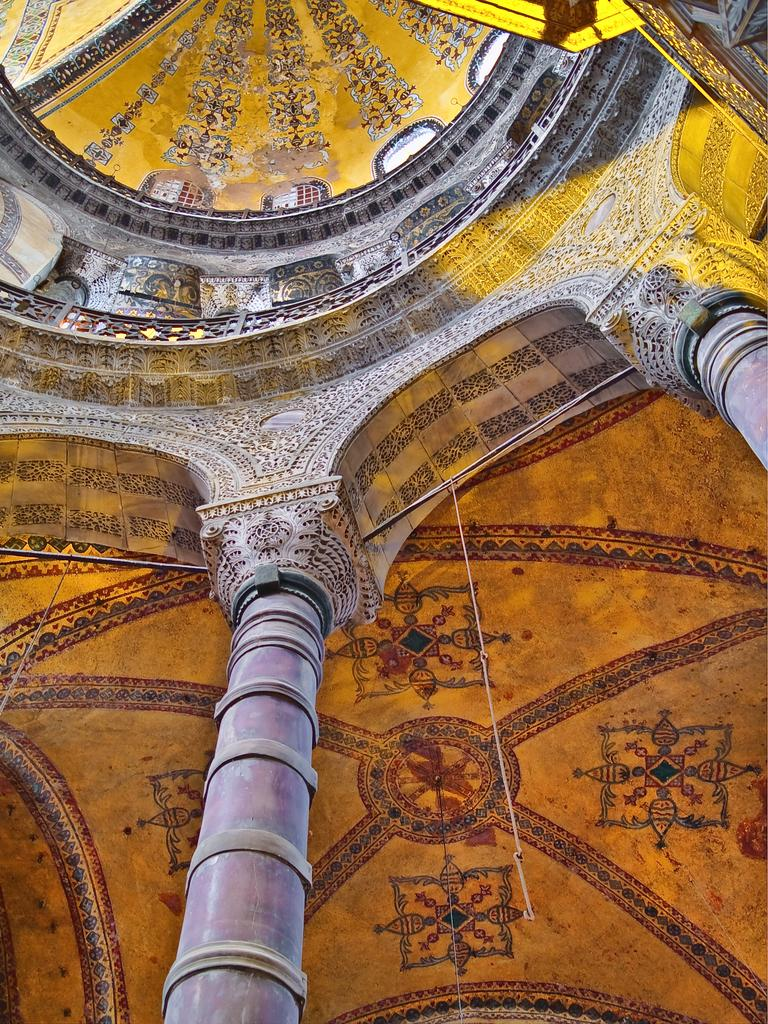What type of location is depicted in the image? The image appears to be an interior view of a building. What architectural features can be seen in the image? There are two pillars visible in the image. What is located at the top of the image? There is a dome at the top of the image. What type of soda is being served in the image? There is no soda present in the image; it depicts an interior view of a building with pillars and a dome. What type of suit is the person wearing in the image? There are no people visible in the image, so it is not possible to determine what type of suit someone might be wearing. 